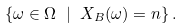<formula> <loc_0><loc_0><loc_500><loc_500>\left \{ \omega \in \Omega \ | \ X _ { B } ( \omega ) = n \right \} .</formula> 